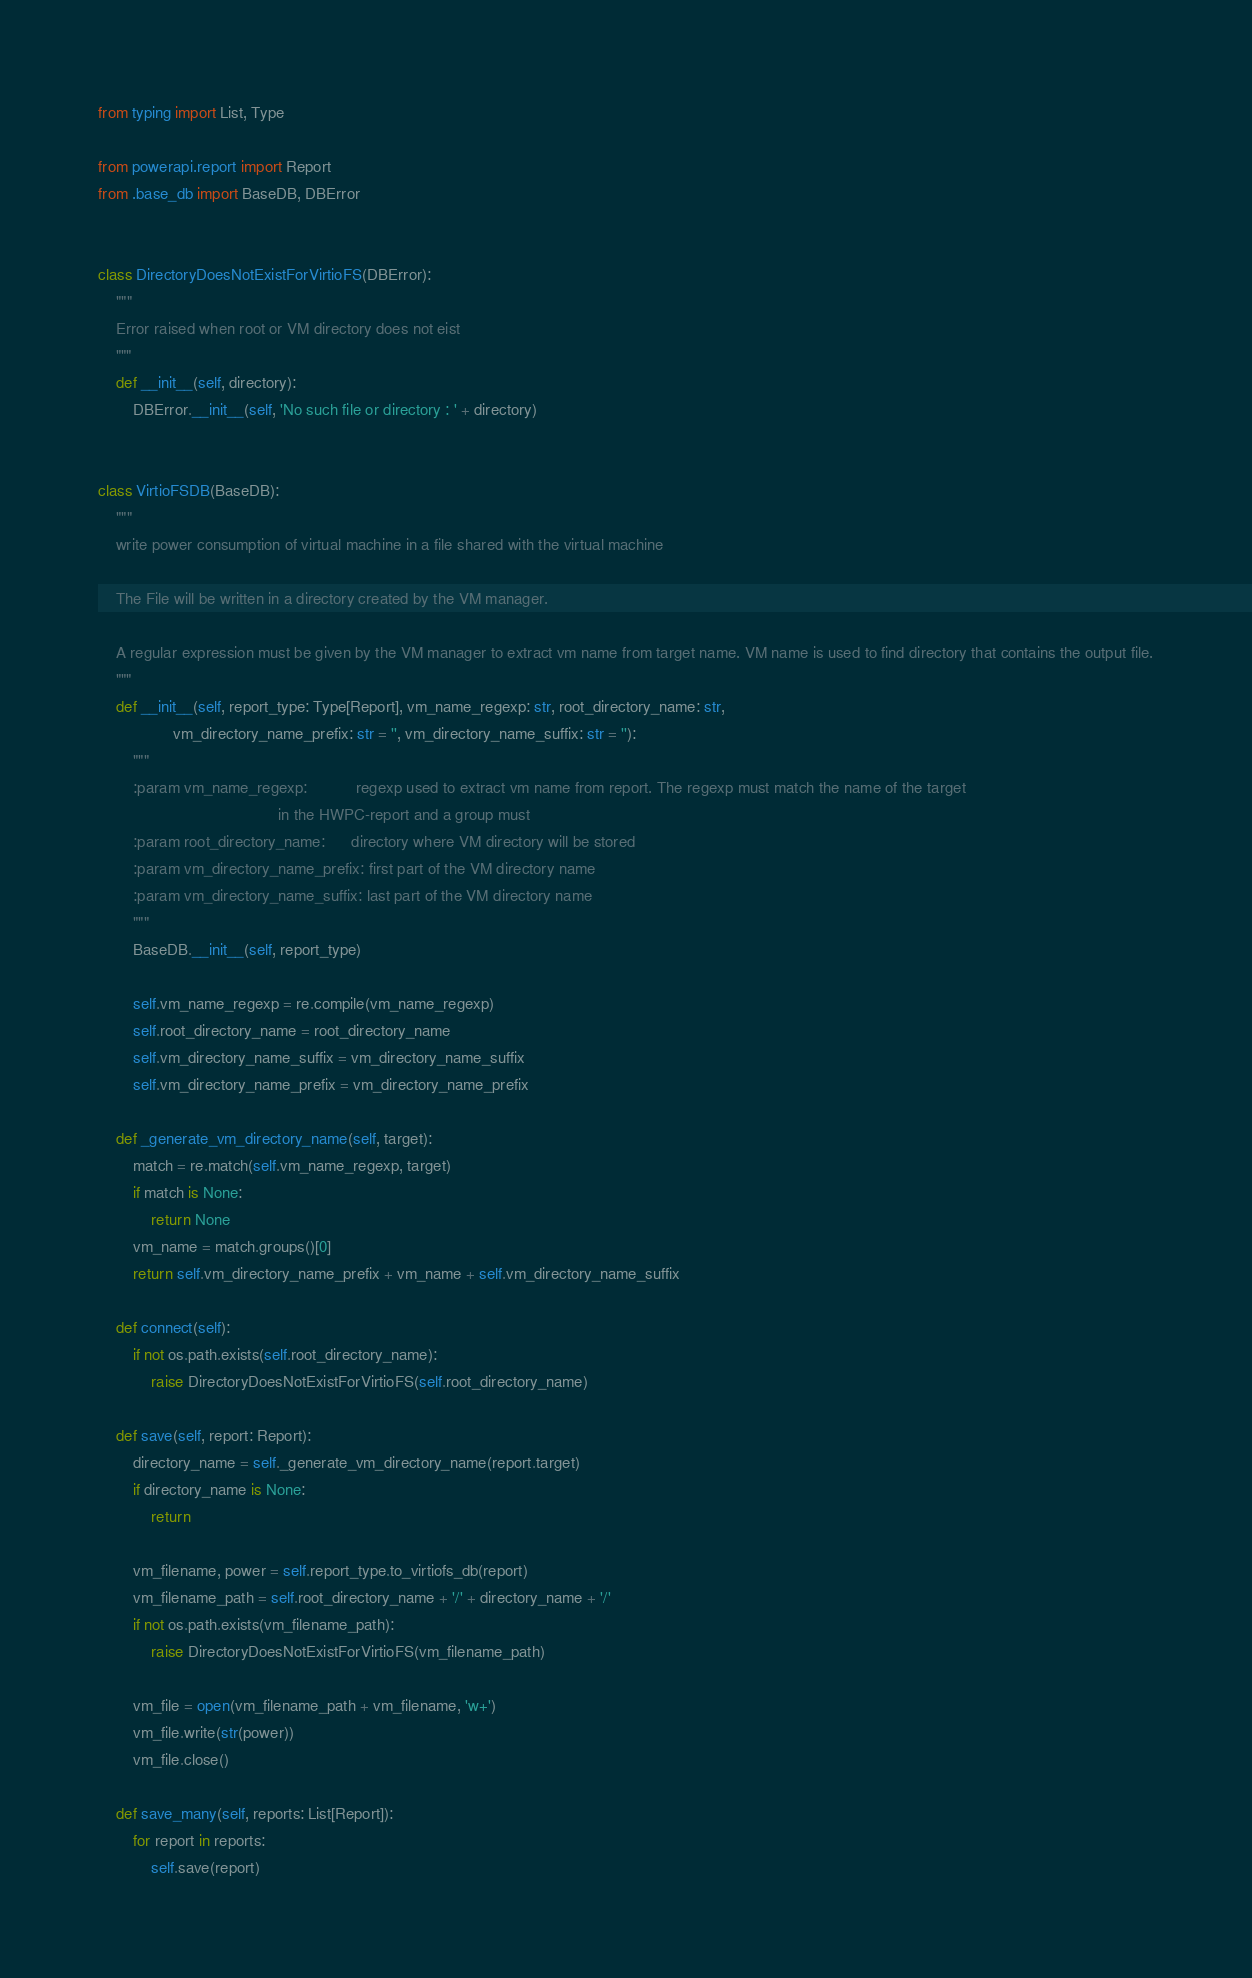Convert code to text. <code><loc_0><loc_0><loc_500><loc_500><_Python_>
from typing import List, Type

from powerapi.report import Report
from .base_db import BaseDB, DBError


class DirectoryDoesNotExistForVirtioFS(DBError):
    """
    Error raised when root or VM directory does not eist
    """
    def __init__(self, directory):
        DBError.__init__(self, 'No such file or directory : ' + directory)


class VirtioFSDB(BaseDB):
    """
    write power consumption of virtual machine in a file shared with the virtual machine

    The File will be written in a directory created by the VM manager.

    A regular expression must be given by the VM manager to extract vm name from target name. VM name is used to find directory that contains the output file.
    """
    def __init__(self, report_type: Type[Report], vm_name_regexp: str, root_directory_name: str,
                 vm_directory_name_prefix: str = '', vm_directory_name_suffix: str = ''):
        """
        :param vm_name_regexp:           regexp used to extract vm name from report. The regexp must match the name of the target
                                         in the HWPC-report and a group must
        :param root_directory_name:      directory where VM directory will be stored
        :param vm_directory_name_prefix: first part of the VM directory name
        :param vm_directory_name_suffix: last part of the VM directory name
        """
        BaseDB.__init__(self, report_type)

        self.vm_name_regexp = re.compile(vm_name_regexp)
        self.root_directory_name = root_directory_name
        self.vm_directory_name_suffix = vm_directory_name_suffix
        self.vm_directory_name_prefix = vm_directory_name_prefix

    def _generate_vm_directory_name(self, target):
        match = re.match(self.vm_name_regexp, target)
        if match is None:
            return None
        vm_name = match.groups()[0]
        return self.vm_directory_name_prefix + vm_name + self.vm_directory_name_suffix

    def connect(self):
        if not os.path.exists(self.root_directory_name):
            raise DirectoryDoesNotExistForVirtioFS(self.root_directory_name)

    def save(self, report: Report):
        directory_name = self._generate_vm_directory_name(report.target)
        if directory_name is None:
            return

        vm_filename, power = self.report_type.to_virtiofs_db(report)
        vm_filename_path = self.root_directory_name + '/' + directory_name + '/'
        if not os.path.exists(vm_filename_path):
            raise DirectoryDoesNotExistForVirtioFS(vm_filename_path)

        vm_file = open(vm_filename_path + vm_filename, 'w+')
        vm_file.write(str(power))
        vm_file.close()

    def save_many(self, reports: List[Report]):
        for report in reports:
            self.save(report)
</code> 